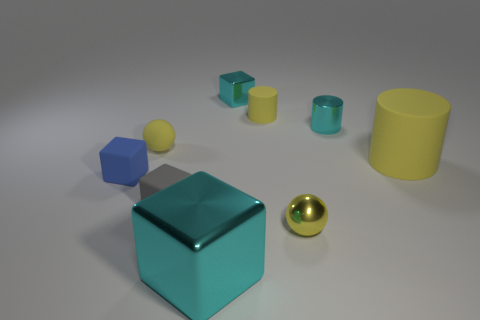There is another cylinder that is the same material as the tiny yellow cylinder; what is its size?
Keep it short and to the point. Large. How many tiny blue matte things are the same shape as the large cyan thing?
Ensure brevity in your answer.  1. How many yellow metal cylinders are there?
Offer a very short reply. 0. There is a blue thing behind the big shiny object; is its shape the same as the gray object?
Your response must be concise. Yes. There is a cyan cube that is the same size as the cyan cylinder; what is its material?
Ensure brevity in your answer.  Metal. Is there a small yellow cylinder made of the same material as the tiny cyan cube?
Keep it short and to the point. No. There is a small blue matte object; is its shape the same as the cyan shiny object in front of the small blue rubber thing?
Keep it short and to the point. Yes. What number of tiny objects are both left of the gray block and behind the large matte cylinder?
Ensure brevity in your answer.  1. Is the material of the cyan cylinder the same as the large yellow object that is in front of the small yellow cylinder?
Offer a very short reply. No. Are there an equal number of small metal cylinders that are in front of the big yellow matte object and large gray cubes?
Ensure brevity in your answer.  Yes. 